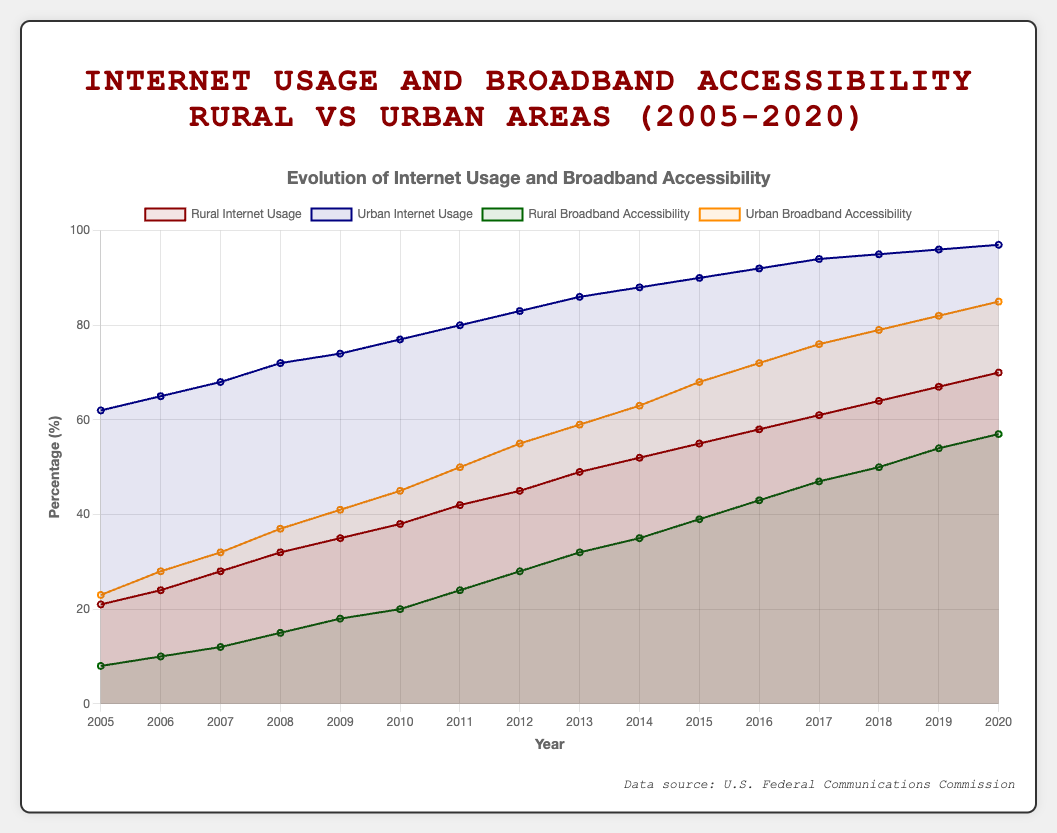What is the difference in Rural Internet Usage between 2005 and 2020? The data shows Rural Internet Usage was 21% in 2005 and increased to 70% in 2020. The difference is calculated as 70% - 21%.
Answer: 49% In 2015, which category had the higher percentage, Urban Internet Usage or Urban Broadband Accessibility? According to the data for 2015, Urban Internet Usage was 90%, while Urban Broadband Accessibility was 68%. Urban Internet Usage had a higher percentage.
Answer: Urban Internet Usage How did Rural Broadband Accessibility change from 2005 to 2020? Rural Broadband Accessibility increased from 8% in 2005 to 57% in 2020. This indicates a growth trend over the 15-year period.
Answer: Increased Which year shows the closest gap between Rural and Urban Internet Usage, and what is this gap? In 2020, Rural Internet Usage was 70% and Urban Internet Usage was 97%. The gap is 97% - 70% = 27%. This is the smallest gap across the years.
Answer: 2020 with a gap of 27% In which year did Urban Broadband Accessibility first exceed 50%? Data indicates Urban Broadband Accessibility reached 50% in 2011.
Answer: 2011 Looking at the trend from 2005 to 2020, which category shows the steepest increase in percentage terms, Rural Broadband Accessibility, or Urban Broadband Accessibility? Rural Broadband Accessibility increased from 8% to 57% (49% increase). Urban Broadband Accessibility increased from 23% to 85% (62% increase). Urban Broadband Accessibility shows the steepest increase.
Answer: Urban Broadband Accessibility What is the average Rural Broadband Accessibility percentage over the 15 years reported? The sum of the Rural Broadband Accessibility percentages from 2005 to 2020 is 467. Dividing this sum by 15 years gives an average of 467/15.
Answer: 31.13% Identify the trend of Urban Internet Usage from 2015 to 2020. Urban Internet Usage rose steadily from 90% in 2015 to 97% in 2020, showing an upward trend.
Answer: Upward Did Rural Internet Usage ever lag by more than 50 percentage points compared to Urban Internet Usage? If yes, identify the year. In the year 2005, Rural Internet Usage was 21% while Urban Internet Usage was 62%, showing a 41 percentage points gap. Thus, Rural Internet Usage never lagged by more than 50 percentage points.
Answer: No What was the combined percentage point increase for both Rural and Urban Broadband Accessibility from 2008 to 2012? Rural Broadband Accessibility increased from 15% to 28% (13 points), and Urban Broadband Accessibility from 37% to 55% (18 points). Combined, this is 13 + 18 = 31 points.
Answer: 31 points 